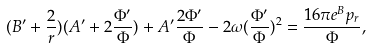<formula> <loc_0><loc_0><loc_500><loc_500>( B ^ { \prime } + \frac { 2 } { r } ) ( A ^ { \prime } + 2 \frac { \Phi ^ { \prime } } { \Phi } ) + A ^ { \prime } \frac { 2 \Phi ^ { \prime } } { \Phi } - 2 \omega ( \frac { \Phi ^ { \prime } } { \Phi } ) ^ { 2 } = \frac { 1 6 \pi e ^ { B } p _ { r } } { \Phi } ,</formula> 